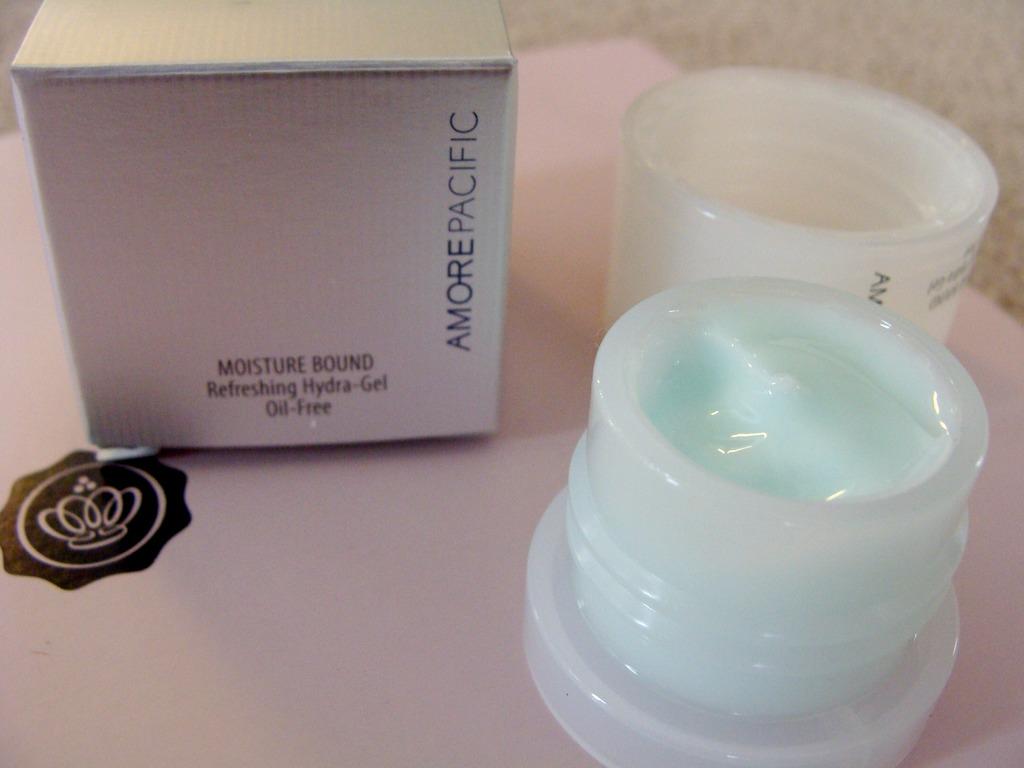What brand is this?
Offer a very short reply. Amore pacific. 